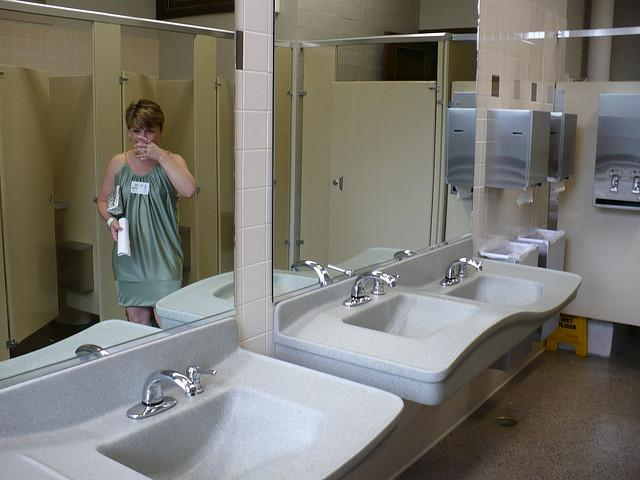What is the woman wearing?

Choices:
A) dress
B) dress
C) jeans
D) pyjamas dress 